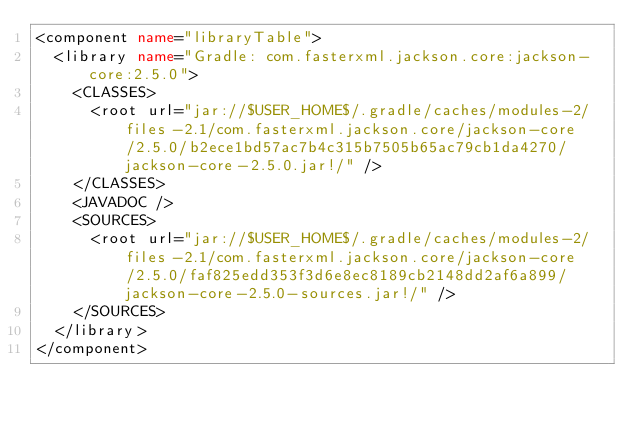<code> <loc_0><loc_0><loc_500><loc_500><_XML_><component name="libraryTable">
  <library name="Gradle: com.fasterxml.jackson.core:jackson-core:2.5.0">
    <CLASSES>
      <root url="jar://$USER_HOME$/.gradle/caches/modules-2/files-2.1/com.fasterxml.jackson.core/jackson-core/2.5.0/b2ece1bd57ac7b4c315b7505b65ac79cb1da4270/jackson-core-2.5.0.jar!/" />
    </CLASSES>
    <JAVADOC />
    <SOURCES>
      <root url="jar://$USER_HOME$/.gradle/caches/modules-2/files-2.1/com.fasterxml.jackson.core/jackson-core/2.5.0/faf825edd353f3d6e8ec8189cb2148dd2af6a899/jackson-core-2.5.0-sources.jar!/" />
    </SOURCES>
  </library>
</component></code> 